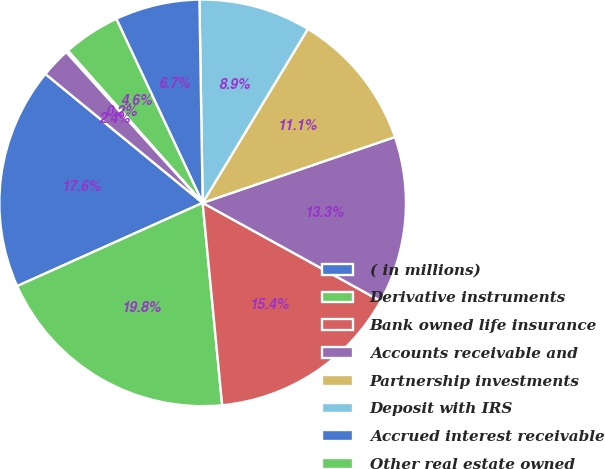<chart> <loc_0><loc_0><loc_500><loc_500><pie_chart><fcel>( in millions)<fcel>Derivative instruments<fcel>Bank owned life insurance<fcel>Accounts receivable and<fcel>Partnership investments<fcel>Deposit with IRS<fcel>Accrued interest receivable<fcel>Other real estate owned<fcel>Prepaid pension and other<fcel>Other<nl><fcel>17.64%<fcel>19.82%<fcel>15.45%<fcel>13.27%<fcel>11.09%<fcel>8.91%<fcel>6.73%<fcel>4.55%<fcel>0.18%<fcel>2.36%<nl></chart> 